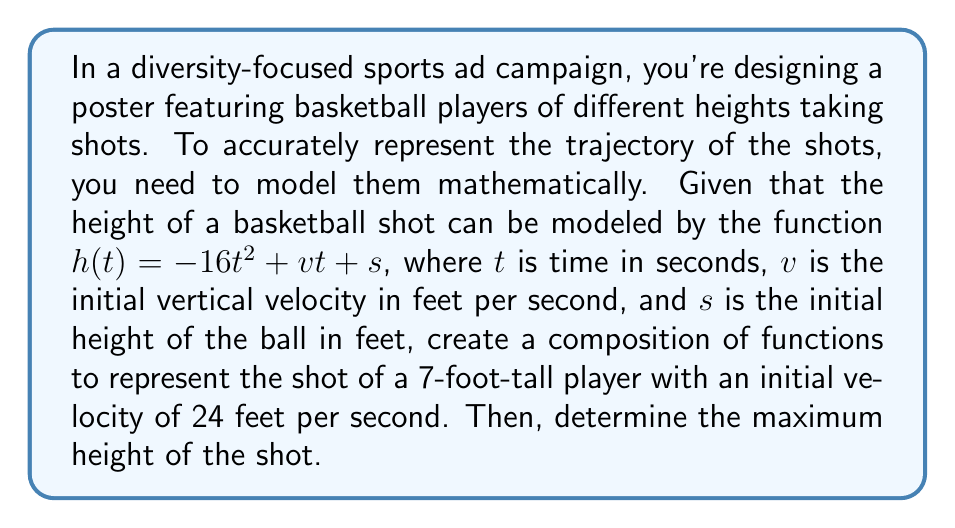Can you solve this math problem? To solve this problem, we'll follow these steps:

1) First, we need to create a composition of functions. The player's height affects the initial height of the ball. Let's assume the player releases the ball about 1 foot above their head. So, we can create a function for the initial height:

   $s(h) = h + 1$, where $h$ is the player's height in feet.

2) Now, we can compose this with the given height function:

   $h(t) = -16t^2 + vt + s(h)$
   $h(t) = -16t^2 + 24t + (7 + 1)$
   $h(t) = -16t^2 + 24t + 8$

3) To find the maximum height, we need to find the vertex of this parabola. The vertex occurs at the axis of symmetry, which we can find using the formula $t = -\frac{b}{2a}$, where $a$ and $b$ are the coefficients of the quadratic function in standard form $(at^2 + bt + c)$.

4) In this case, $a = -16$ and $b = 24$. So:

   $t = -\frac{24}{2(-16)} = \frac{24}{32} = \frac{3}{4} = 0.75$ seconds

5) To find the maximum height, we plug this $t$ value back into our function:

   $h(0.75) = -16(0.75)^2 + 24(0.75) + 8$
   $= -16(0.5625) + 18 + 8$
   $= -9 + 18 + 8$
   $= 17$ feet

Therefore, the maximum height of the shot is 17 feet.
Answer: The maximum height of the basketball shot is 17 feet, occurring at 0.75 seconds after the shot is released. 